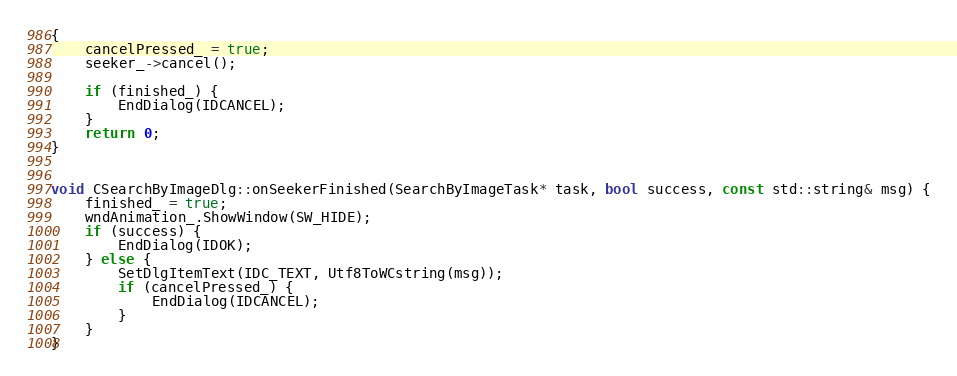<code> <loc_0><loc_0><loc_500><loc_500><_C++_>{
    cancelPressed_ = true;
    seeker_->cancel();

    if (finished_) {
        EndDialog(IDCANCEL);
    }
    return 0;
}


void CSearchByImageDlg::onSeekerFinished(SearchByImageTask* task, bool success, const std::string& msg) {
    finished_ = true;
    wndAnimation_.ShowWindow(SW_HIDE);
    if (success) {
        EndDialog(IDOK);
    } else {
        SetDlgItemText(IDC_TEXT, Utf8ToWCstring(msg));
        if (cancelPressed_) {
            EndDialog(IDCANCEL);
        }
    }
}</code> 